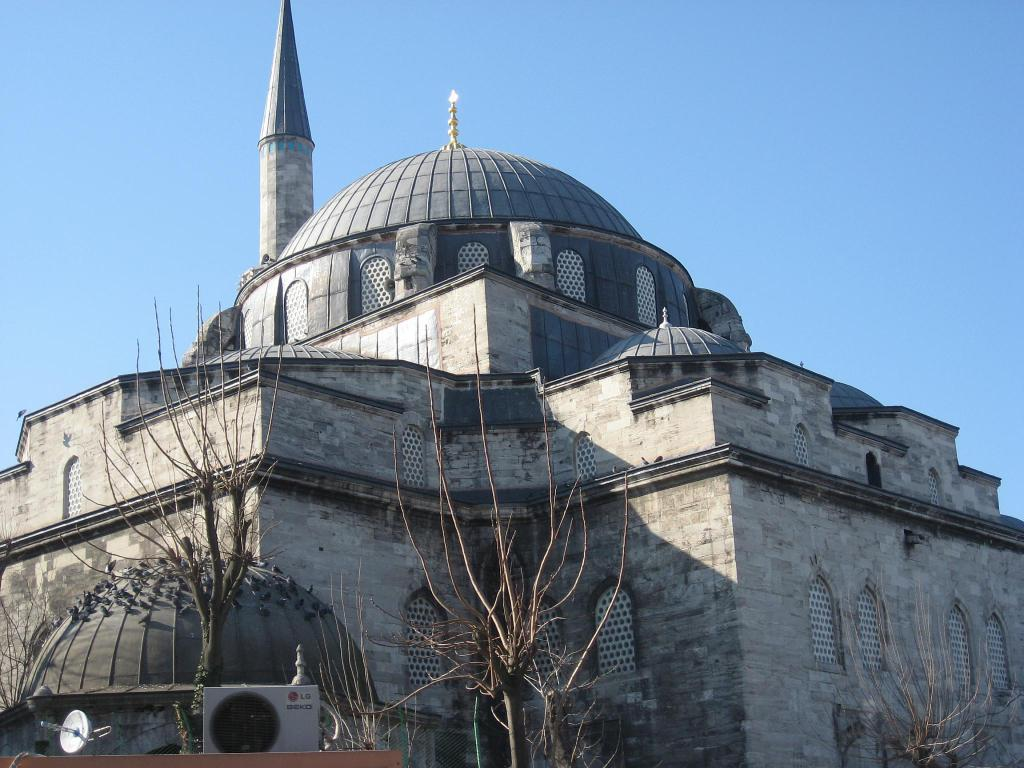What is the main subject of the image? The main subject of the image is an architecture. What can be seen in front of the architecture? There are dry trees in front of the architecture. What type of pollution is visible around the architecture in the image? There is no visible pollution around the architecture in the image. What kind of bread is being used to construct the architecture? The architecture is not made of bread; it is a solid structure. 